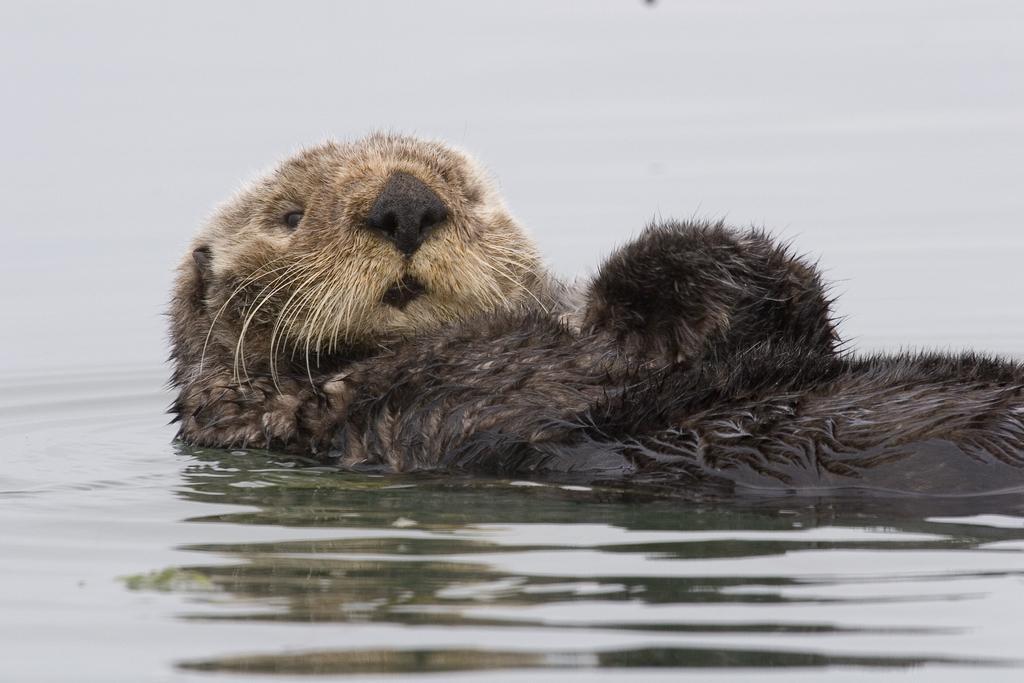Can you describe this image briefly? In this image, we can see an animal and some water. 